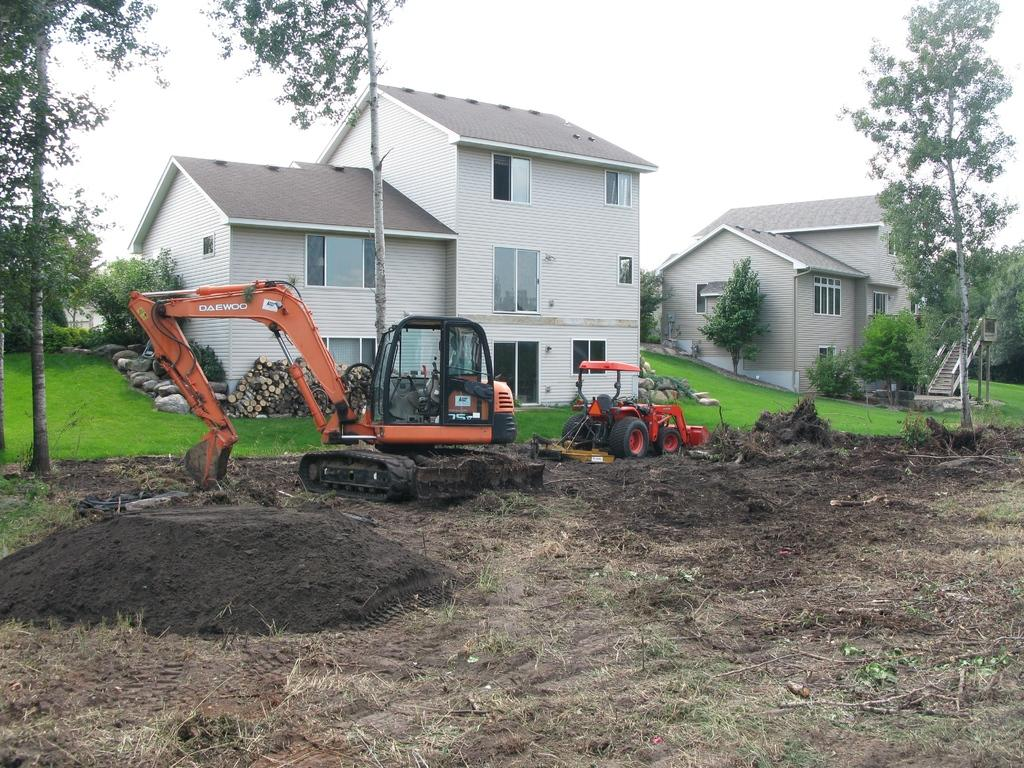What type of land is shown in the image? There is a land in the image. What machinery can be seen on the land? There is a crane and a tractor on the land. What can be seen in the background of the image? There is a grassland, houses, trees, and the sky visible in the background of the image. What type of loaf is being taught to the students in the image? There is no loaf or students present in the image; it features a land with a crane and a tractor. What reason does the crane have for being on the land in the image? The image does not provide any information about the reason for the crane being on the land. 